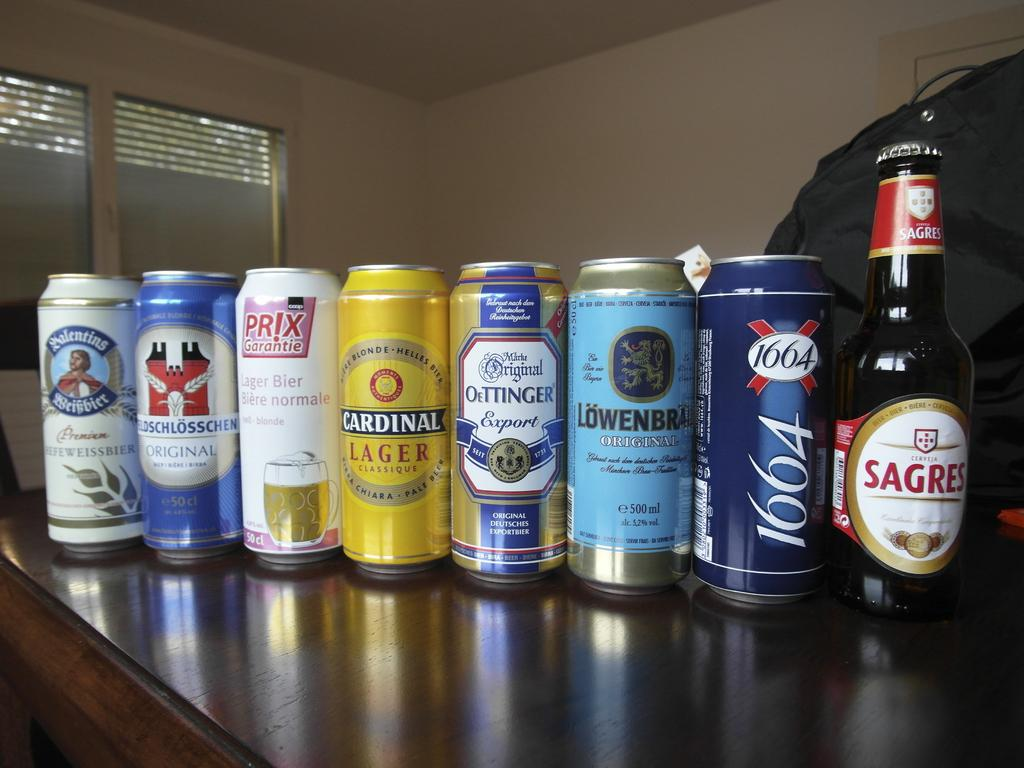<image>
Provide a brief description of the given image. Various beer cans as well as one bottle. One of them reads Cardinal Lager. They all appear to be German. 